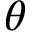Convert formula to latex. <formula><loc_0><loc_0><loc_500><loc_500>\theta</formula> 